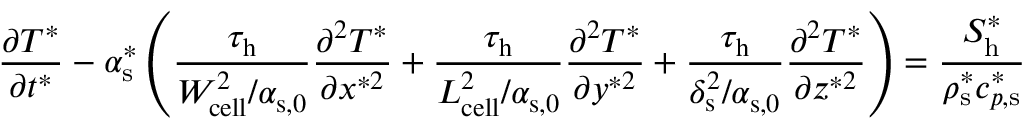Convert formula to latex. <formula><loc_0><loc_0><loc_500><loc_500>\frac { \partial T ^ { * } } { \partial t ^ { * } } - \alpha _ { s } ^ { * } \left ( \frac { \tau _ { h } } { W _ { c e l l } ^ { 2 } / \alpha _ { s , 0 } } \frac { \partial ^ { 2 } T ^ { * } } { \partial x ^ { * 2 } } + \frac { \tau _ { h } } { L _ { c e l l } ^ { 2 } / \alpha _ { s , 0 } } \frac { \partial ^ { 2 } T ^ { * } } { \partial y ^ { * 2 } } + \frac { \tau _ { h } } { \delta _ { s } ^ { 2 } / \alpha _ { s , 0 } } \frac { \partial ^ { 2 } T ^ { * } } { \partial z ^ { * 2 } } \right ) = \frac { S _ { h } ^ { * } } { \rho _ { s } ^ { * } c _ { p , s } ^ { * } }</formula> 